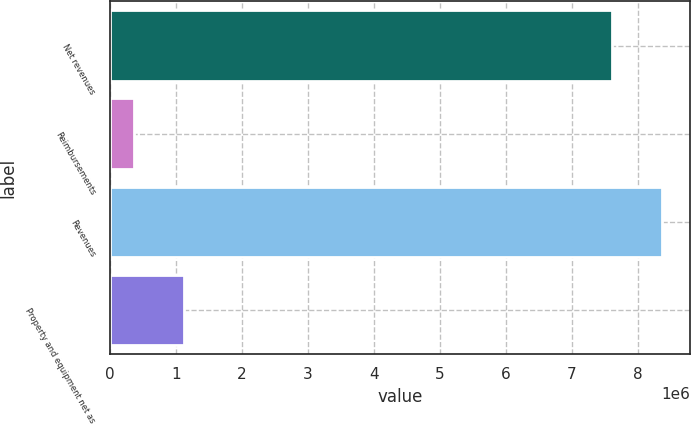Convert chart. <chart><loc_0><loc_0><loc_500><loc_500><bar_chart><fcel>Net revenues<fcel>Reimbursements<fcel>Revenues<fcel>Property and equipment net as<nl><fcel>7.61282e+06<fcel>364650<fcel>8.3741e+06<fcel>1.12593e+06<nl></chart> 